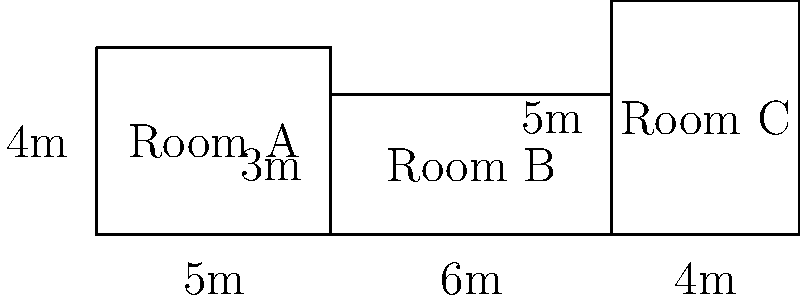As an adolescent psychiatrist designing a new mental health ward for young offenders, you need to calculate the total floor area for three rectangular rooms. Room A is 5m by 4m, Room B is 6m by 3m, and Room C is 4m by 5m. What is the total floor area of these three rooms combined? To find the total floor area, we need to calculate the area of each room and then sum them up:

1. Area of Room A:
   $A_A = 5m \times 4m = 20m^2$

2. Area of Room B:
   $A_B = 6m \times 3m = 18m^2$

3. Area of Room C:
   $A_C = 4m \times 5m = 20m^2$

4. Total area:
   $A_{total} = A_A + A_B + A_C$
   $A_{total} = 20m^2 + 18m^2 + 20m^2 = 58m^2$

Therefore, the total floor area of the three rooms combined is 58 square meters.
Answer: $58m^2$ 